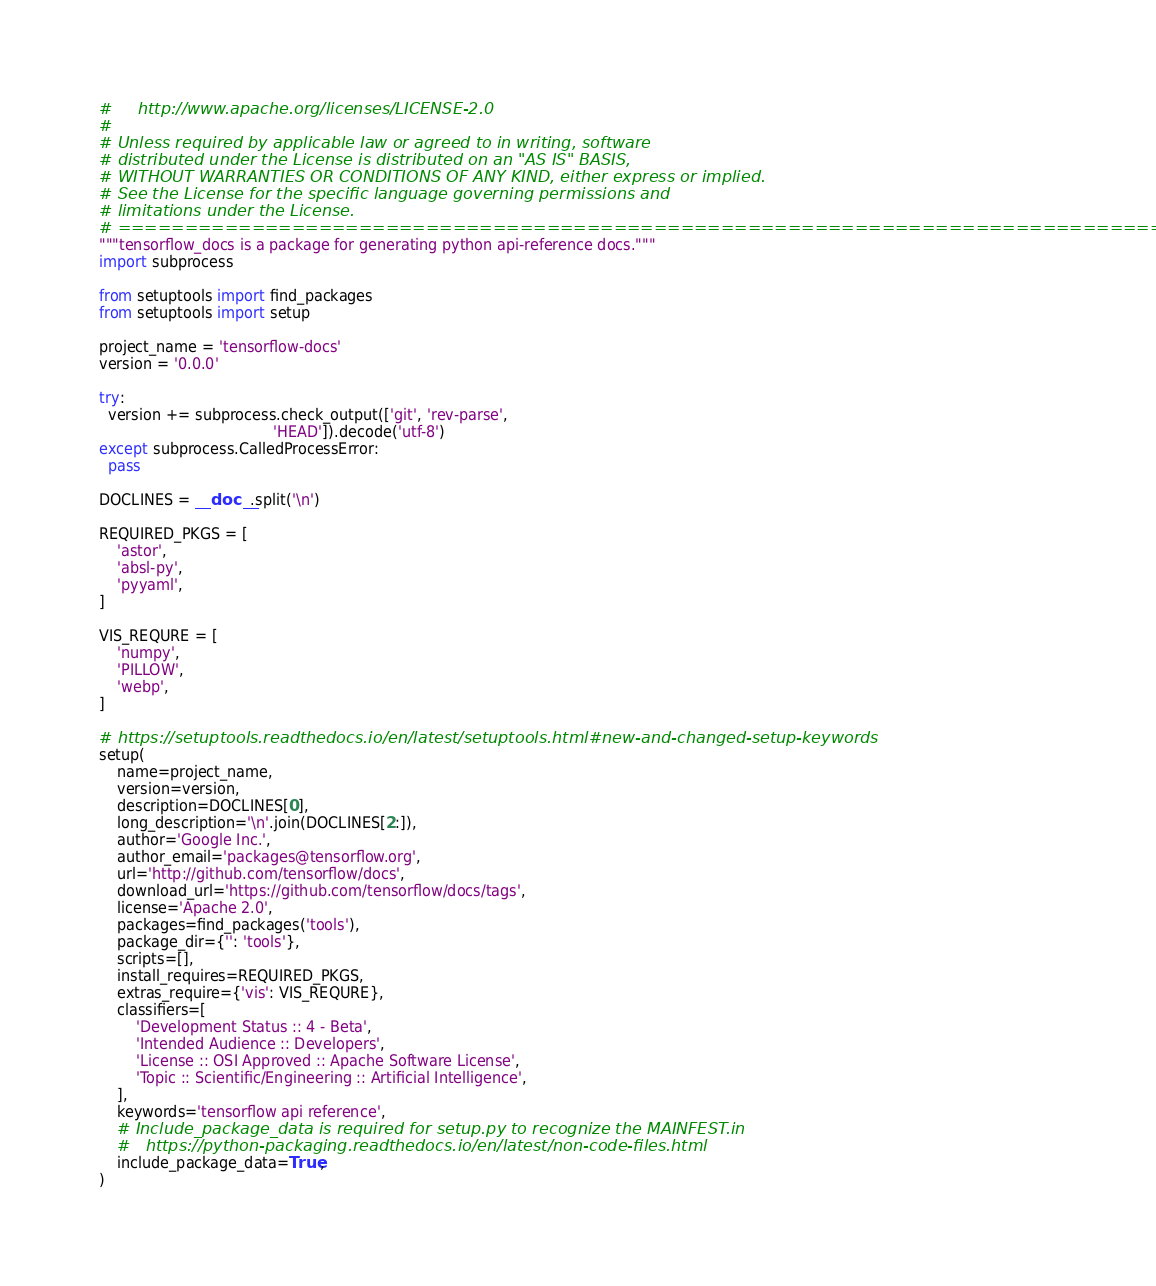Convert code to text. <code><loc_0><loc_0><loc_500><loc_500><_Python_>#     http://www.apache.org/licenses/LICENSE-2.0
#
# Unless required by applicable law or agreed to in writing, software
# distributed under the License is distributed on an "AS IS" BASIS,
# WITHOUT WARRANTIES OR CONDITIONS OF ANY KIND, either express or implied.
# See the License for the specific language governing permissions and
# limitations under the License.
# ==============================================================================
"""tensorflow_docs is a package for generating python api-reference docs."""
import subprocess

from setuptools import find_packages
from setuptools import setup

project_name = 'tensorflow-docs'
version = '0.0.0'

try:
  version += subprocess.check_output(['git', 'rev-parse',
                                      'HEAD']).decode('utf-8')
except subprocess.CalledProcessError:
  pass

DOCLINES = __doc__.split('\n')

REQUIRED_PKGS = [
    'astor',
    'absl-py',
    'pyyaml',
]

VIS_REQURE = [
    'numpy',
    'PILLOW',
    'webp',
]

# https://setuptools.readthedocs.io/en/latest/setuptools.html#new-and-changed-setup-keywords
setup(
    name=project_name,
    version=version,
    description=DOCLINES[0],
    long_description='\n'.join(DOCLINES[2:]),
    author='Google Inc.',
    author_email='packages@tensorflow.org',
    url='http://github.com/tensorflow/docs',
    download_url='https://github.com/tensorflow/docs/tags',
    license='Apache 2.0',
    packages=find_packages('tools'),
    package_dir={'': 'tools'},
    scripts=[],
    install_requires=REQUIRED_PKGS,
    extras_require={'vis': VIS_REQURE},
    classifiers=[
        'Development Status :: 4 - Beta',
        'Intended Audience :: Developers',
        'License :: OSI Approved :: Apache Software License',
        'Topic :: Scientific/Engineering :: Artificial Intelligence',
    ],
    keywords='tensorflow api reference',
    # Include_package_data is required for setup.py to recognize the MAINFEST.in
    #   https://python-packaging.readthedocs.io/en/latest/non-code-files.html
    include_package_data=True,
)
</code> 